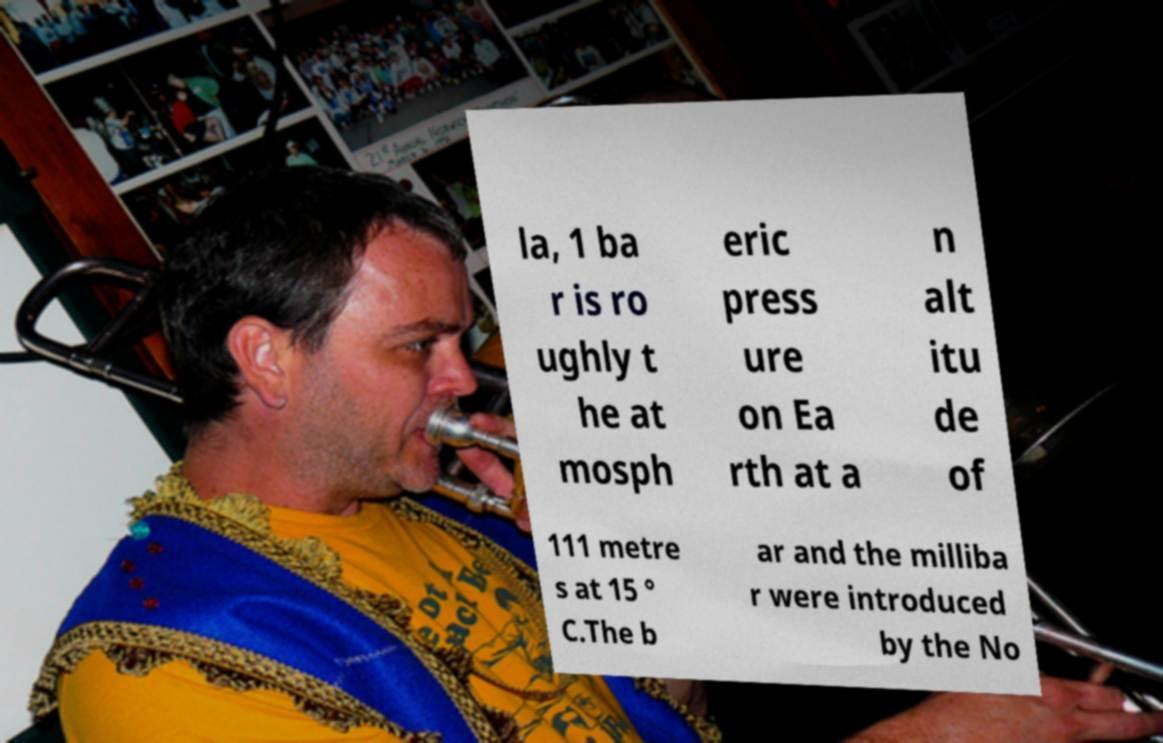There's text embedded in this image that I need extracted. Can you transcribe it verbatim? la, 1 ba r is ro ughly t he at mosph eric press ure on Ea rth at a n alt itu de of 111 metre s at 15 ° C.The b ar and the milliba r were introduced by the No 